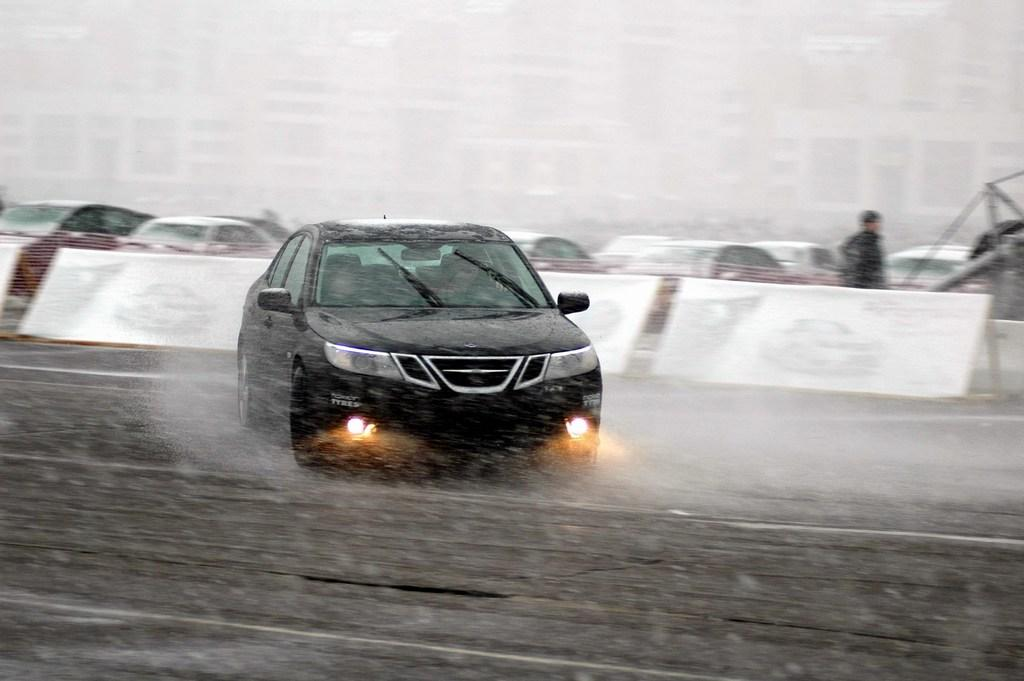What type of vehicles can be seen in the image? There are cars in the image. Can you describe the appearance of the cars? The cars are in different colors. What objects are also present in the image? There are whiteboards in the image. Who or what else can be seen in the image? There is a person in the image. What is the color of the background in the image? The background of the image is white. What type of club can be seen in the image? There is no club present in the image. Is the person in the image using their thumb for any specific purpose? There is no indication in the image that the person is using their thumb for any specific purpose. 